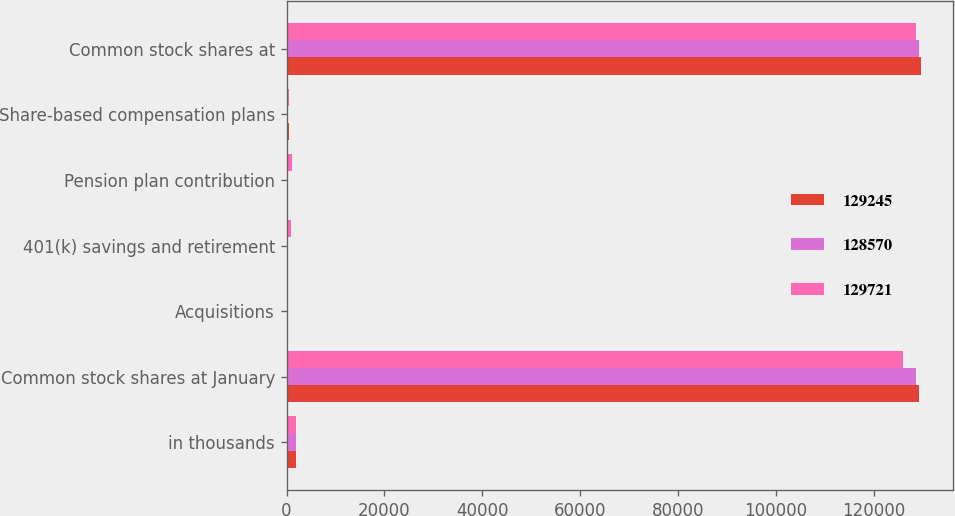Convert chart. <chart><loc_0><loc_0><loc_500><loc_500><stacked_bar_chart><ecel><fcel>in thousands<fcel>Common stock shares at January<fcel>Acquisitions<fcel>401(k) savings and retirement<fcel>Pension plan contribution<fcel>Share-based compensation plans<fcel>Common stock shares at<nl><fcel>129245<fcel>2012<fcel>129245<fcel>61<fcel>0<fcel>0<fcel>415<fcel>129721<nl><fcel>128570<fcel>2011<fcel>128570<fcel>373<fcel>111<fcel>0<fcel>191<fcel>129245<nl><fcel>129721<fcel>2010<fcel>125912<fcel>0<fcel>882<fcel>1190<fcel>586<fcel>128570<nl></chart> 